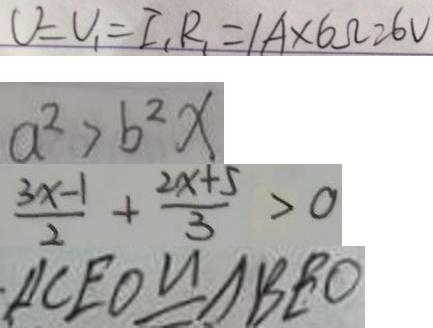Convert formula to latex. <formula><loc_0><loc_0><loc_500><loc_500>V = V _ { 1 } = I _ { 1 } R _ { 1 } = 1 A \times 6 \Omega = 6 V 
 a ^ { 2 } > b ^ { 2 } x 
 \frac { 3 x - 1 } { 2 } + \frac { 2 x + 5 } { 3 } > 0 
 \Delta C E O \cong \Delta B E O</formula> 